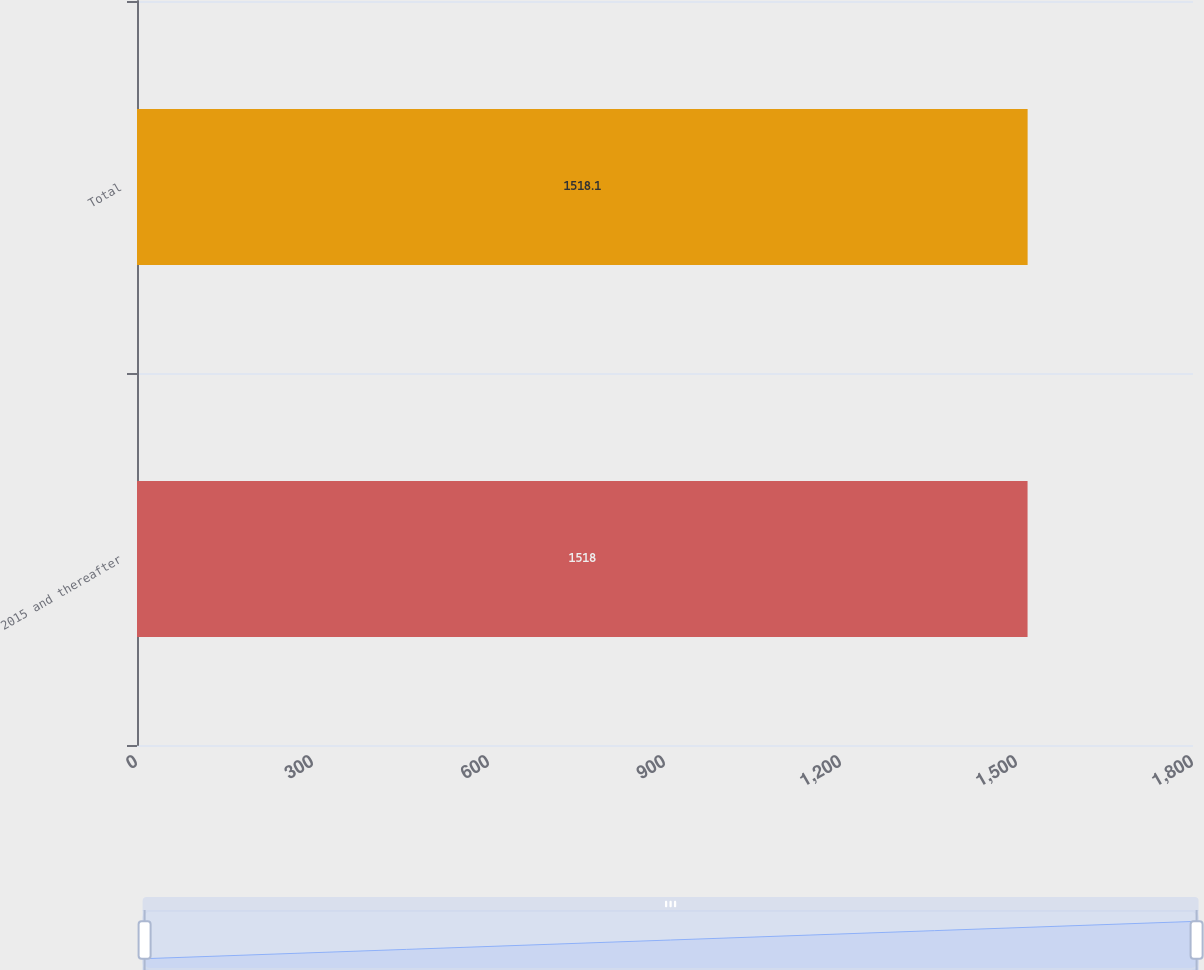Convert chart to OTSL. <chart><loc_0><loc_0><loc_500><loc_500><bar_chart><fcel>2015 and thereafter<fcel>Total<nl><fcel>1518<fcel>1518.1<nl></chart> 